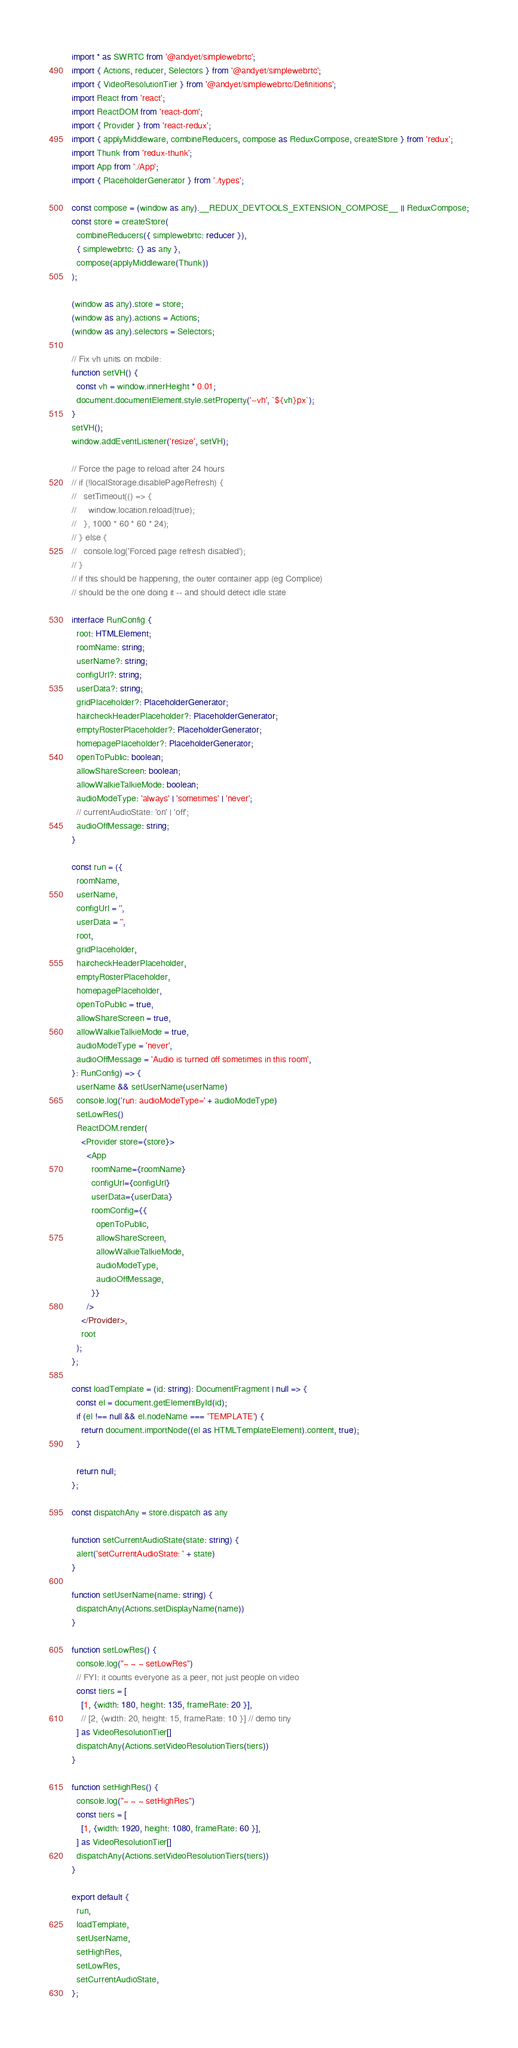<code> <loc_0><loc_0><loc_500><loc_500><_TypeScript_>import * as SWRTC from '@andyet/simplewebrtc';
import { Actions, reducer, Selectors } from '@andyet/simplewebrtc';
import { VideoResolutionTier } from '@andyet/simplewebrtc/Definitions';
import React from 'react';
import ReactDOM from 'react-dom';
import { Provider } from 'react-redux';
import { applyMiddleware, combineReducers, compose as ReduxCompose, createStore } from 'redux';
import Thunk from 'redux-thunk';
import App from './App';
import { PlaceholderGenerator } from './types';

const compose = (window as any).__REDUX_DEVTOOLS_EXTENSION_COMPOSE__ || ReduxCompose;
const store = createStore(
  combineReducers({ simplewebrtc: reducer }),
  { simplewebrtc: {} as any },
  compose(applyMiddleware(Thunk))
);

(window as any).store = store;
(window as any).actions = Actions;
(window as any).selectors = Selectors;

// Fix vh units on mobile:
function setVH() {
  const vh = window.innerHeight * 0.01;
  document.documentElement.style.setProperty('--vh', `${vh}px`);
}
setVH();
window.addEventListener('resize', setVH);

// Force the page to reload after 24 hours
// if (!localStorage.disablePageRefresh) {
//   setTimeout(() => {
//     window.location.reload(true);
//   }, 1000 * 60 * 60 * 24);
// } else {
//   console.log('Forced page refresh disabled');
// }
// if this should be happening, the outer container app (eg Complice)
// should be the one doing it -- and should detect idle state

interface RunConfig {
  root: HTMLElement;
  roomName: string;
  userName?: string;
  configUrl?: string;
  userData?: string;
  gridPlaceholder?: PlaceholderGenerator;
  haircheckHeaderPlaceholder?: PlaceholderGenerator;
  emptyRosterPlaceholder?: PlaceholderGenerator;
  homepagePlaceholder?: PlaceholderGenerator;
  openToPublic: boolean;
  allowShareScreen: boolean;
  allowWalkieTalkieMode: boolean;
  audioModeType: 'always' | 'sometimes' | 'never';
  // currentAudioState: 'on' | 'off';
  audioOffMessage: string;
}

const run = ({
  roomName,
  userName,
  configUrl = '',
  userData = '',
  root,
  gridPlaceholder,
  haircheckHeaderPlaceholder,
  emptyRosterPlaceholder,
  homepagePlaceholder,
  openToPublic = true,
  allowShareScreen = true,
  allowWalkieTalkieMode = true,
  audioModeType = 'never',
  audioOffMessage = 'Audio is turned off sometimes in this room',
}: RunConfig) => {
  userName && setUserName(userName)
  console.log('run: audioModeType=' + audioModeType)
  setLowRes()
  ReactDOM.render(
    <Provider store={store}>
      <App
        roomName={roomName}
        configUrl={configUrl}
        userData={userData}
        roomConfig={{
          openToPublic,
          allowShareScreen,
          allowWalkieTalkieMode,
          audioModeType,
          audioOffMessage,
        }}
      />
    </Provider>,
    root
  );
};

const loadTemplate = (id: string): DocumentFragment | null => {
  const el = document.getElementById(id);
  if (el !== null && el.nodeName === 'TEMPLATE') {
    return document.importNode((el as HTMLTemplateElement).content, true);
  }

  return null;
};

const dispatchAny = store.dispatch as any

function setCurrentAudioState(state: string) {
  alert('setCurrentAudioState: ' + state)
}

function setUserName(name: string) {
  dispatchAny(Actions.setDisplayName(name))
}

function setLowRes() {
  console.log("~ ~ ~ setLowRes")
  // FYI: it counts everyone as a peer, not just people on video
  const tiers = [
    [1, {width: 180, height: 135, frameRate: 20 }],
    // [2, {width: 20, height: 15, frameRate: 10 }] // demo tiny
  ] as VideoResolutionTier[]
  dispatchAny(Actions.setVideoResolutionTiers(tiers))
}

function setHighRes() {
  console.log("~ ~ ~ setHighRes")
  const tiers = [
    [1, {width: 1920, height: 1080, frameRate: 60 }],
  ] as VideoResolutionTier[]
  dispatchAny(Actions.setVideoResolutionTiers(tiers))
}

export default {
  run,
  loadTemplate,
  setUserName,
  setHighRes,
  setLowRes,
  setCurrentAudioState,
};
</code> 